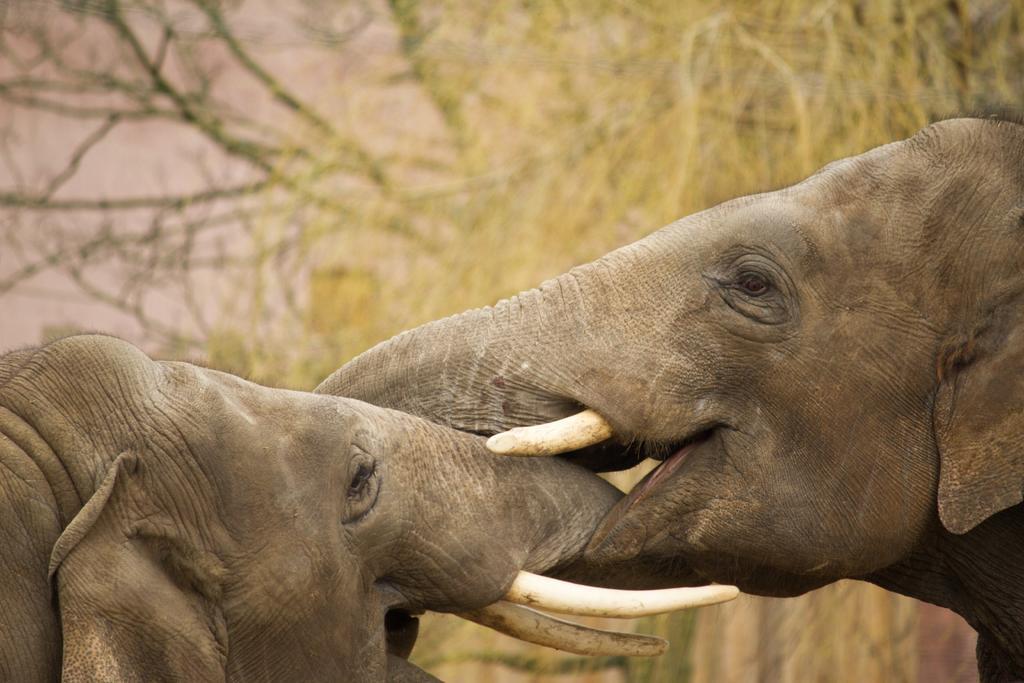Can you describe this image briefly? In this image we can see two elephants and trees in the background. 